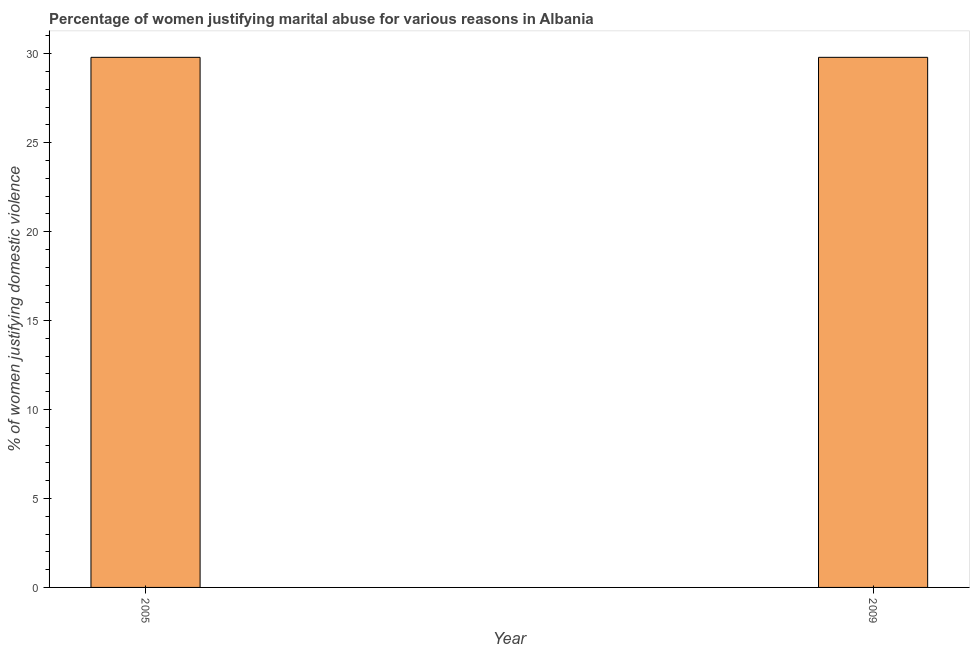Does the graph contain any zero values?
Give a very brief answer. No. Does the graph contain grids?
Offer a terse response. No. What is the title of the graph?
Give a very brief answer. Percentage of women justifying marital abuse for various reasons in Albania. What is the label or title of the X-axis?
Provide a succinct answer. Year. What is the label or title of the Y-axis?
Offer a very short reply. % of women justifying domestic violence. What is the percentage of women justifying marital abuse in 2009?
Make the answer very short. 29.8. Across all years, what is the maximum percentage of women justifying marital abuse?
Offer a very short reply. 29.8. Across all years, what is the minimum percentage of women justifying marital abuse?
Offer a terse response. 29.8. In which year was the percentage of women justifying marital abuse maximum?
Ensure brevity in your answer.  2005. In which year was the percentage of women justifying marital abuse minimum?
Provide a succinct answer. 2005. What is the sum of the percentage of women justifying marital abuse?
Offer a terse response. 59.6. What is the average percentage of women justifying marital abuse per year?
Your response must be concise. 29.8. What is the median percentage of women justifying marital abuse?
Keep it short and to the point. 29.8. How many bars are there?
Offer a terse response. 2. How many years are there in the graph?
Make the answer very short. 2. What is the difference between two consecutive major ticks on the Y-axis?
Ensure brevity in your answer.  5. What is the % of women justifying domestic violence in 2005?
Make the answer very short. 29.8. What is the % of women justifying domestic violence of 2009?
Make the answer very short. 29.8. 